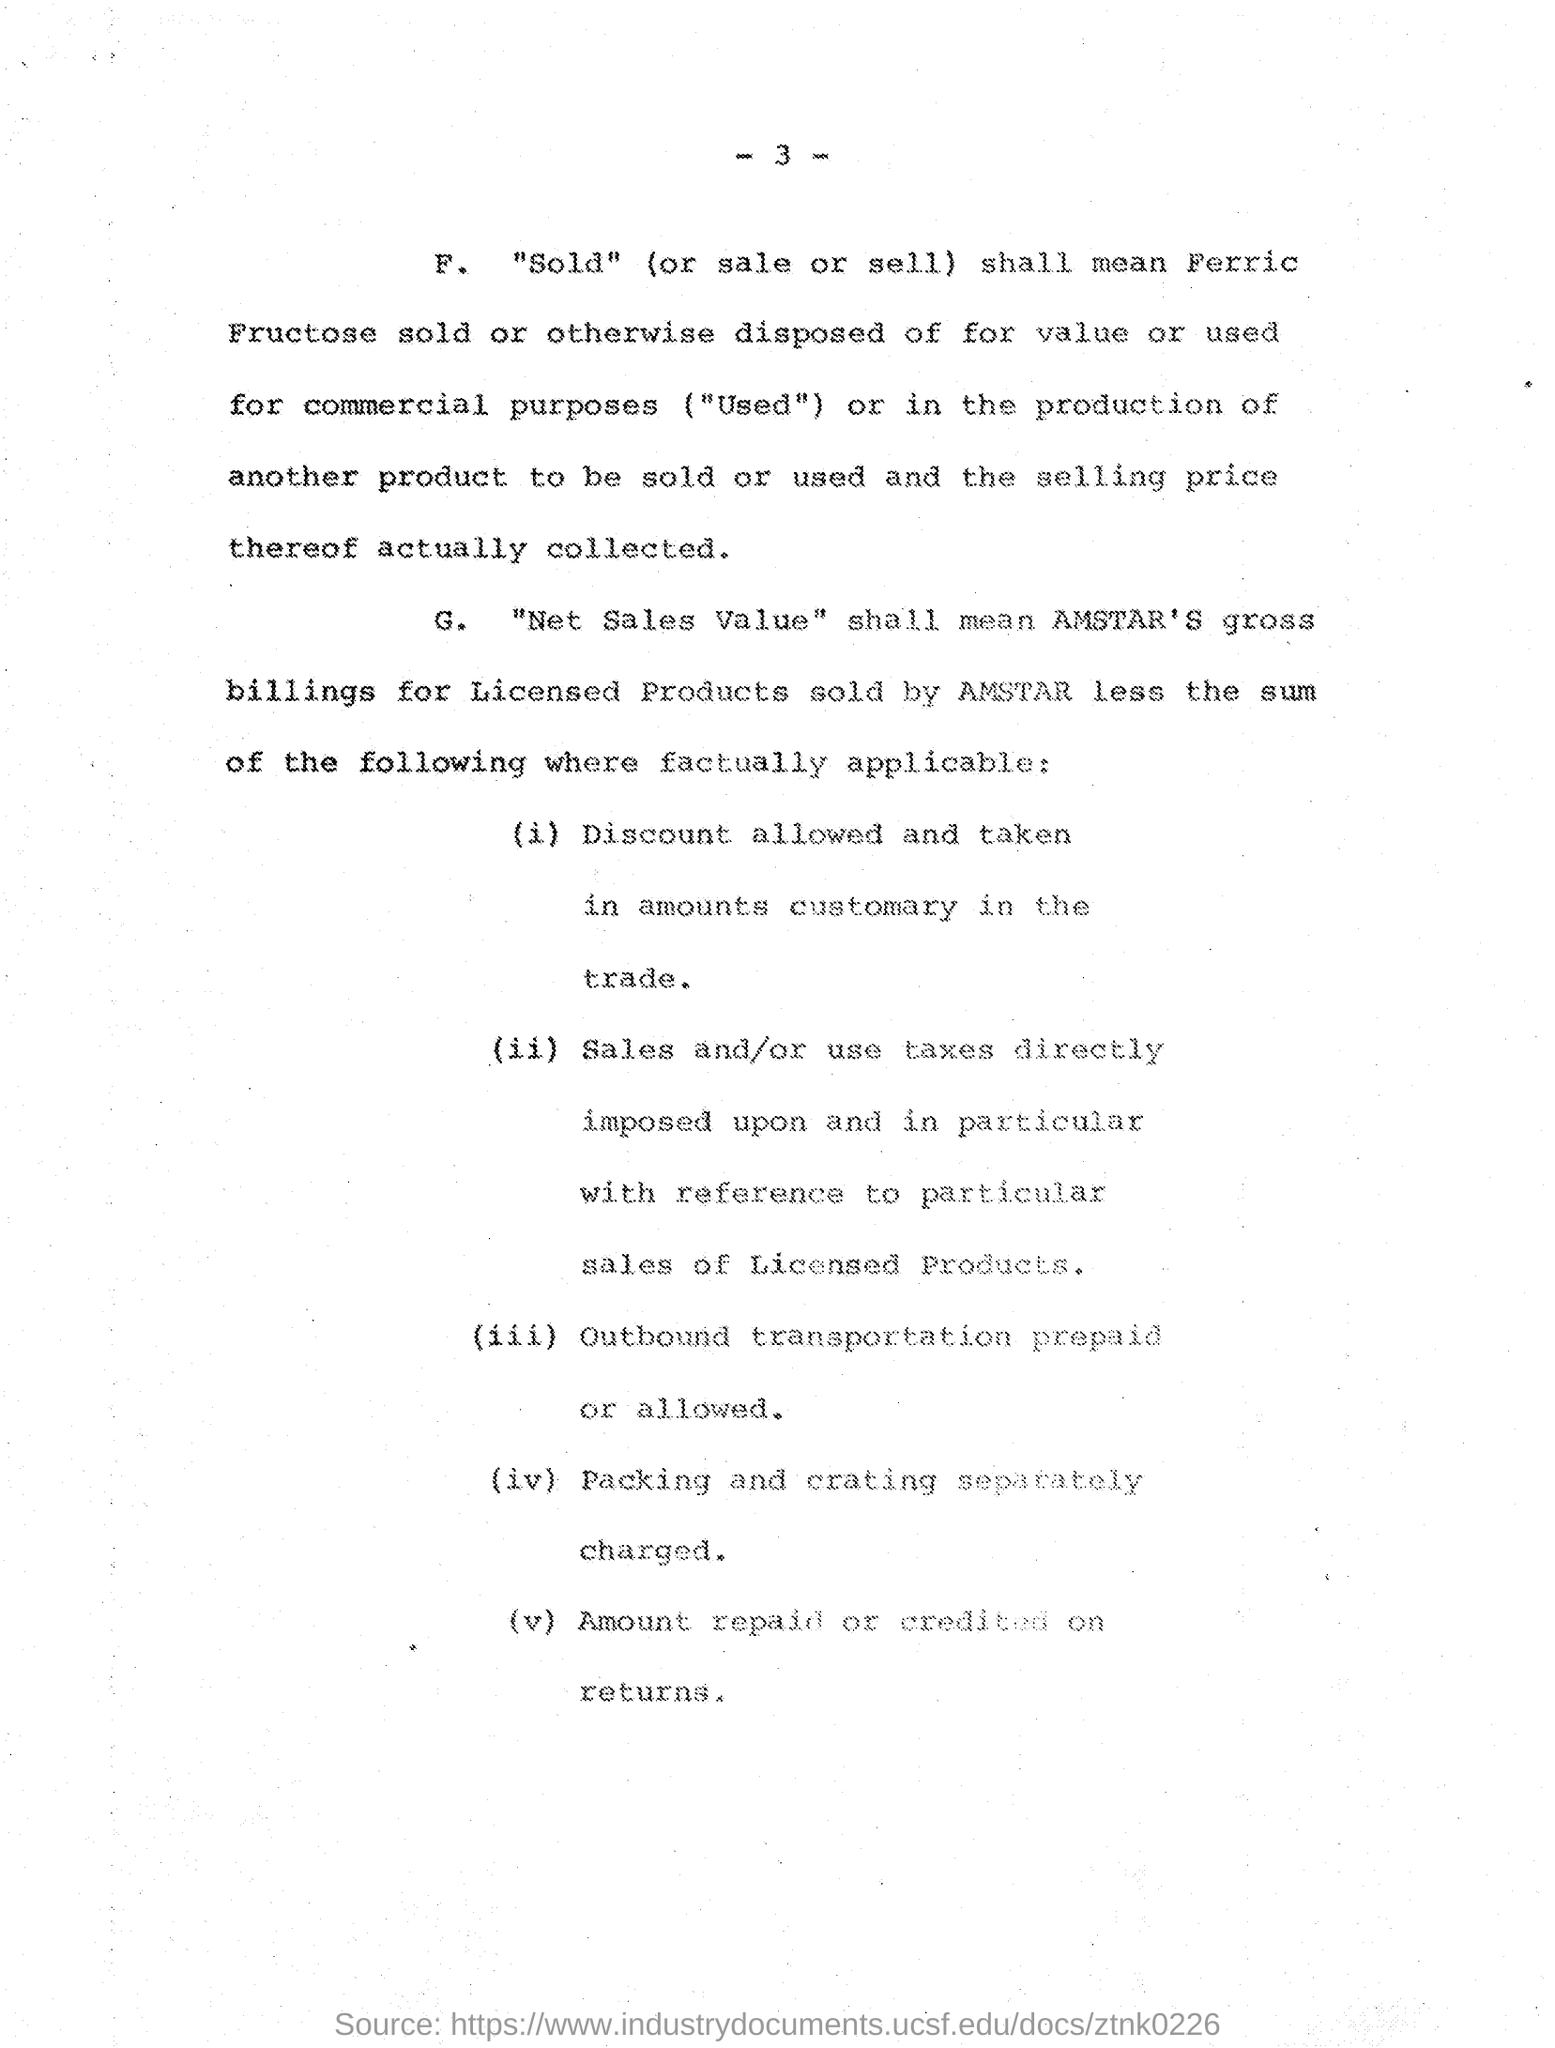What is the number of this page which is written in top ?
Offer a terse response. -3-. For what, it is separately charged?
Your response must be concise. Packing and crating. 